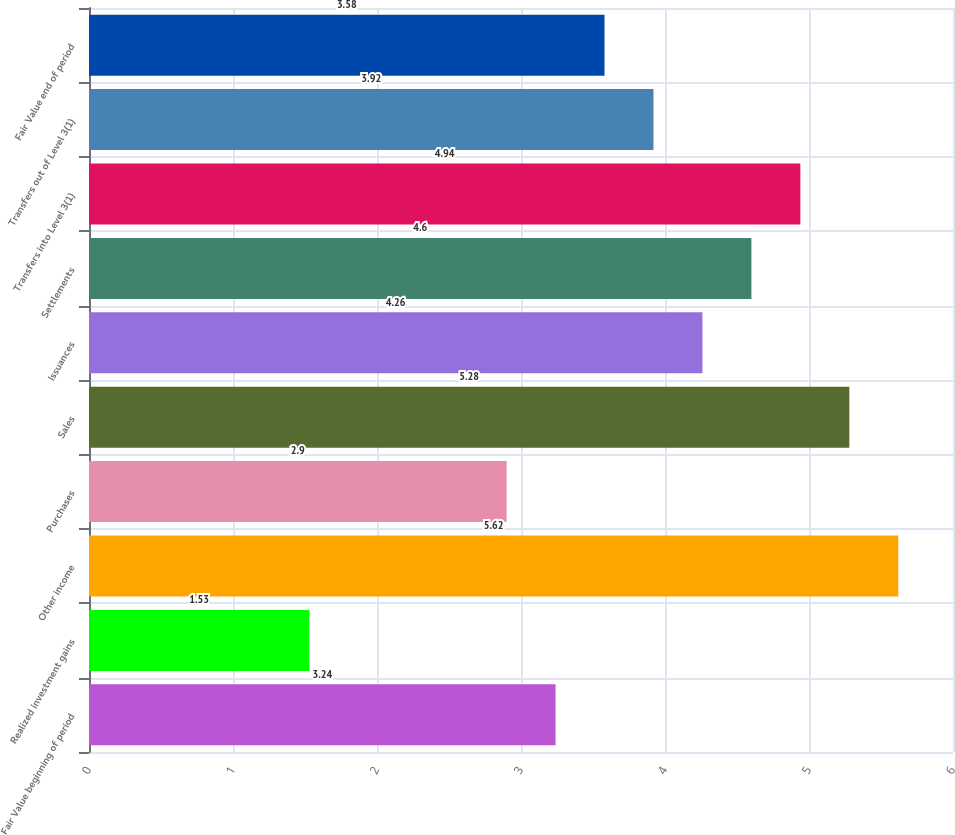Convert chart. <chart><loc_0><loc_0><loc_500><loc_500><bar_chart><fcel>Fair Value beginning of period<fcel>Realized investment gains<fcel>Other income<fcel>Purchases<fcel>Sales<fcel>Issuances<fcel>Settlements<fcel>Transfers into Level 3(1)<fcel>Transfers out of Level 3(1)<fcel>Fair Value end of period<nl><fcel>3.24<fcel>1.53<fcel>5.62<fcel>2.9<fcel>5.28<fcel>4.26<fcel>4.6<fcel>4.94<fcel>3.92<fcel>3.58<nl></chart> 